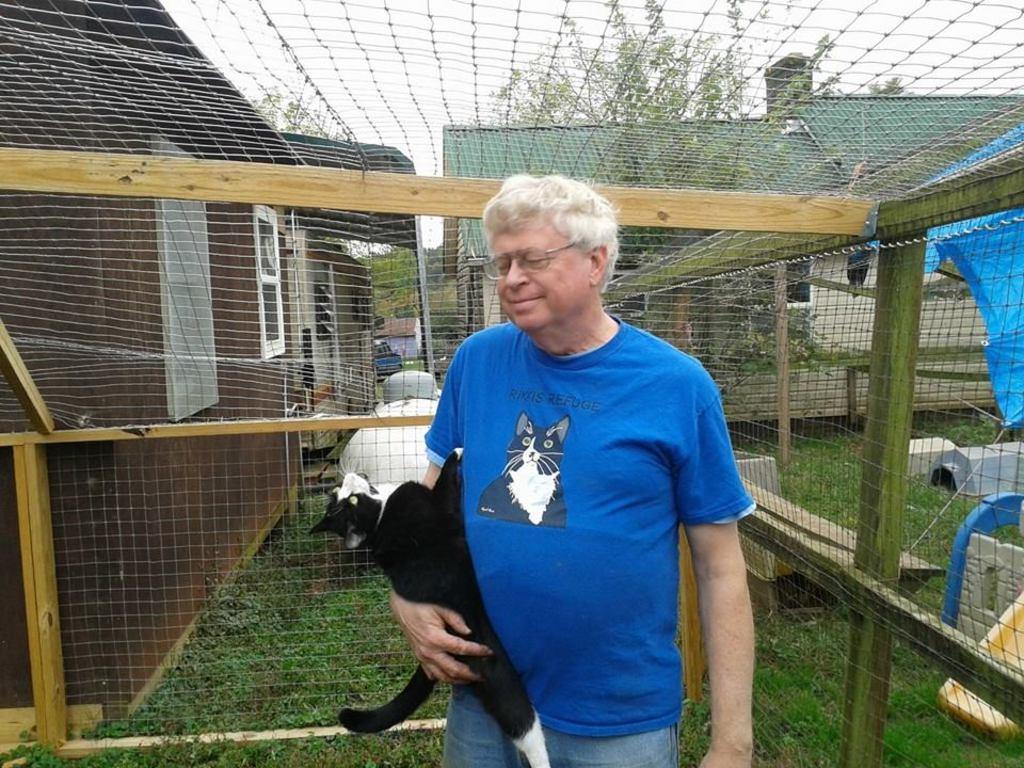How would you summarize this image in a sentence or two? In this image there is a man with glasses and blue t shirt and holding a cat and he is standing on the grass. Behind the man there is a fence and behind the fence we can see houses and also trees. Sky is also visible. 